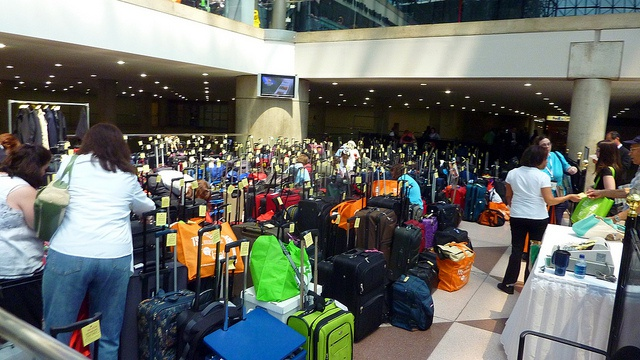Describe the objects in this image and their specific colors. I can see suitcase in white, black, gray, and maroon tones, people in white, blue, black, and navy tones, people in white, black, lightgray, darkgray, and lightblue tones, suitcase in white, blue, black, and navy tones, and suitcase in white, black, olive, darkgreen, and gray tones in this image. 